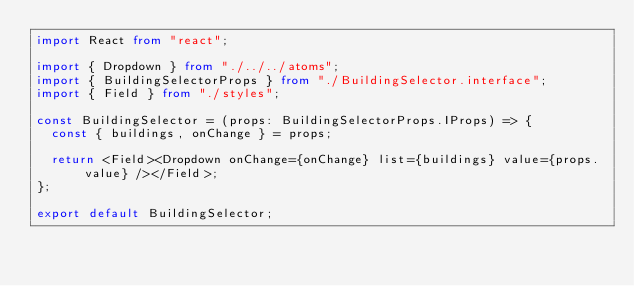<code> <loc_0><loc_0><loc_500><loc_500><_TypeScript_>import React from "react";

import { Dropdown } from "./../../atoms";
import { BuildingSelectorProps } from "./BuildingSelector.interface";
import { Field } from "./styles";

const BuildingSelector = (props: BuildingSelectorProps.IProps) => {
  const { buildings, onChange } = props;

  return <Field><Dropdown onChange={onChange} list={buildings} value={props.value} /></Field>;
};

export default BuildingSelector;
</code> 